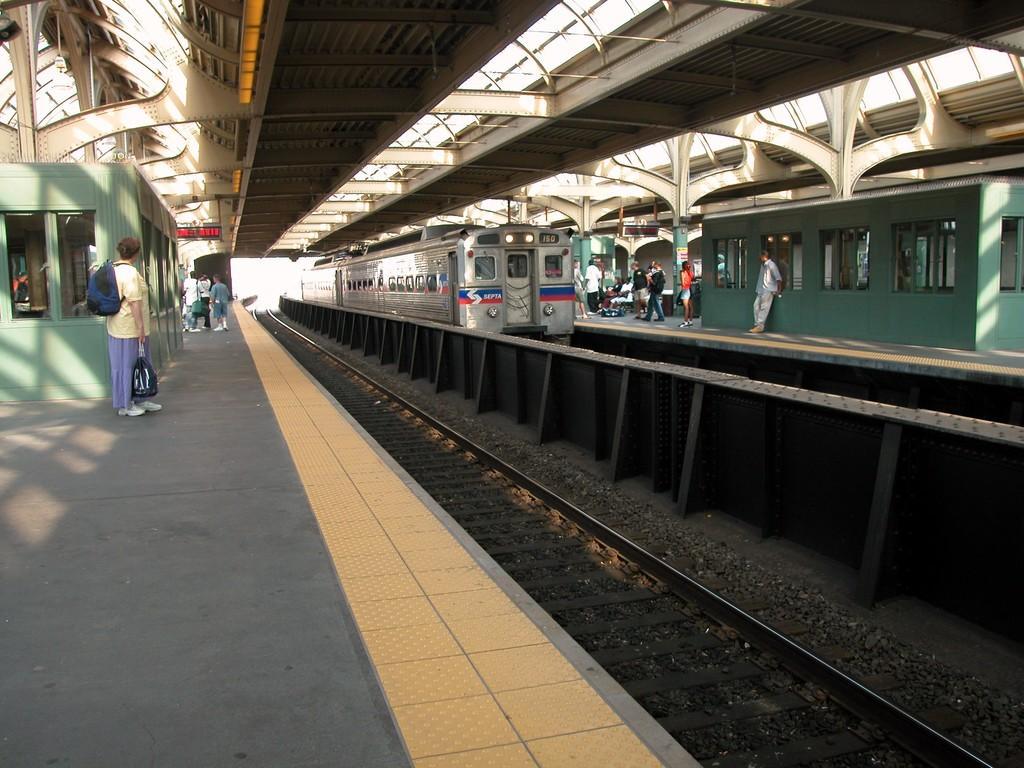How would you summarize this image in a sentence or two? In the picture we can see a railways station platform with some people are standing on it and beside it we can see the track and beside it we can see a train and beside it also we can see a platform with some people on it and top of it we can see the shed. 